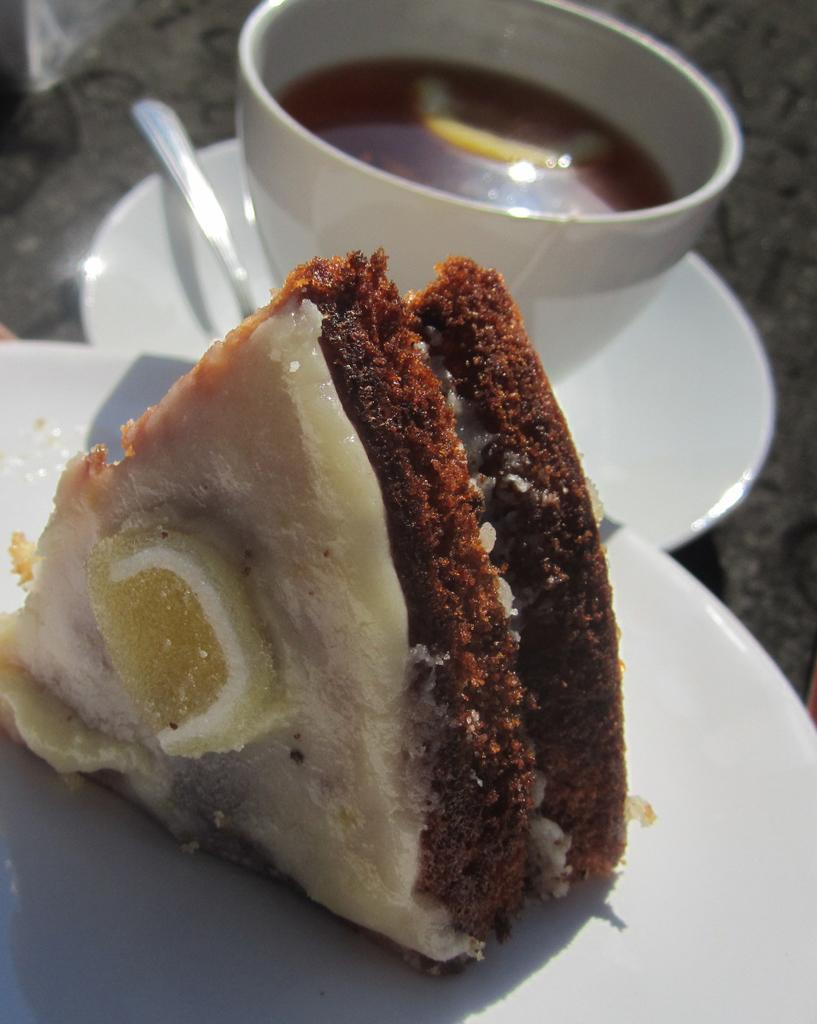What is located in the foreground of the image? There is a plate in the foreground of the image. What is on the plate? There is a pastry on the plate. What is located in the background of the image? There is a cup in the background of the image. What is associated with the cup? There is a saucer associated with the cup. What utensil is present in the background of the image? There is a spoon in the background of the image. What is in the cup? There is a drink in the cup. What type of property is being sold in the image? There is no property being sold in the image; it features a plate with a pastry, a cup with a drink, a saucer, and a spoon. What hobbies are the people in the image engaged in? There are no people present in the image, so their hobbies cannot be determined. 